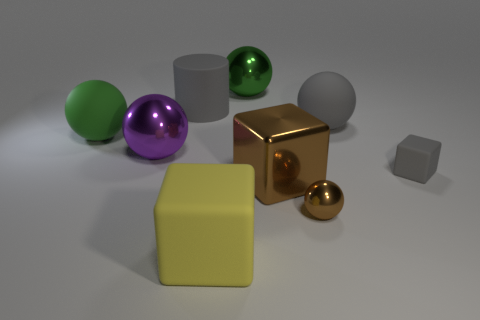Subtract all brown cubes. How many cubes are left? 2 Add 1 tiny cyan metal things. How many objects exist? 10 Subtract all brown cubes. How many cubes are left? 2 Subtract all blocks. How many objects are left? 6 Add 5 blocks. How many blocks exist? 8 Subtract 0 purple cubes. How many objects are left? 9 Subtract 1 spheres. How many spheres are left? 4 Subtract all gray spheres. Subtract all cyan blocks. How many spheres are left? 4 Subtract all yellow cylinders. How many red spheres are left? 0 Subtract all green matte spheres. Subtract all purple metallic objects. How many objects are left? 7 